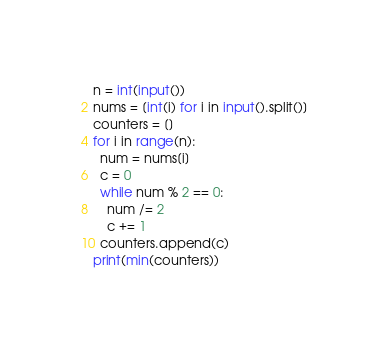<code> <loc_0><loc_0><loc_500><loc_500><_Python_>n = int(input())
nums = [int(i) for i in input().split()]
counters = []
for i in range(n):
  num = nums[i]
  c = 0
  while num % 2 == 0:
    num /= 2
    c += 1
  counters.append(c)
print(min(counters))</code> 